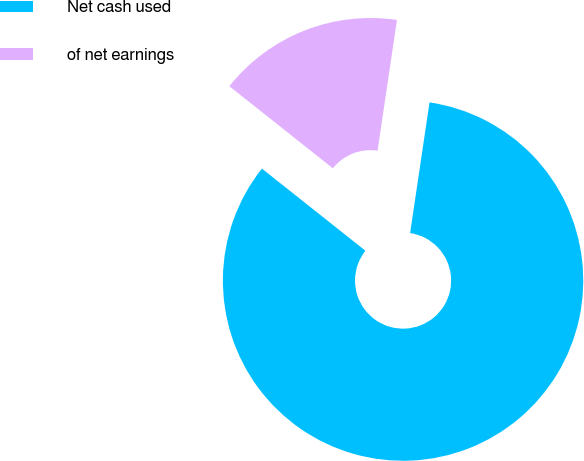Convert chart to OTSL. <chart><loc_0><loc_0><loc_500><loc_500><pie_chart><fcel>Net cash used<fcel>of net earnings<nl><fcel>83.33%<fcel>16.67%<nl></chart> 